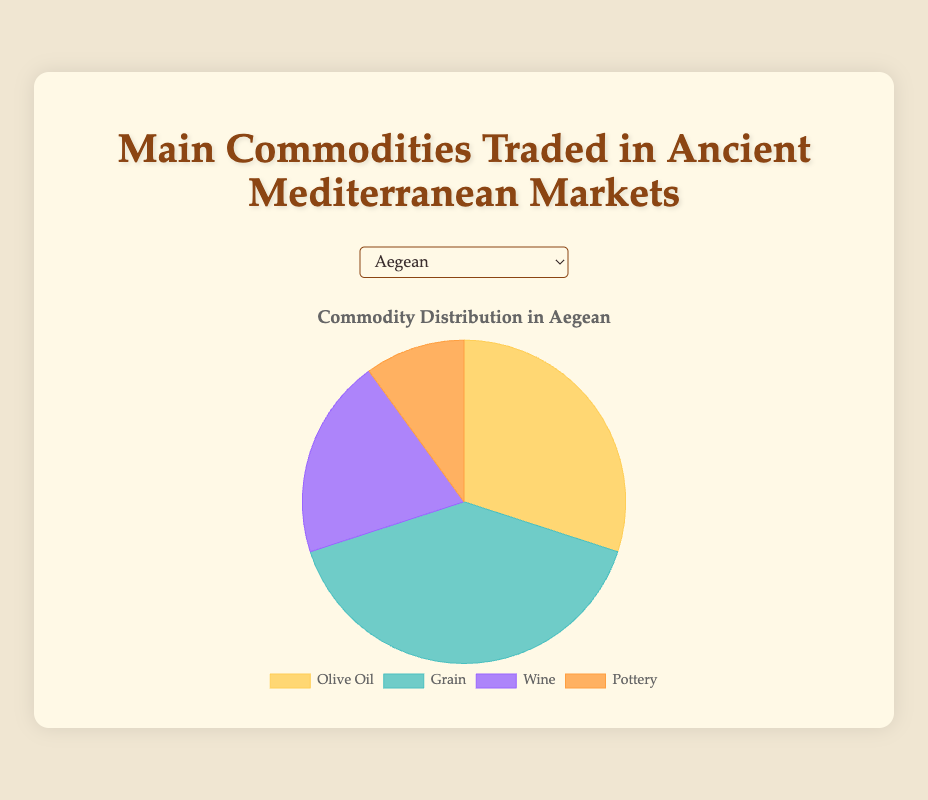What percentage of the commodities in the Aegean region is Olive Oil? To find this, refer to the pie chart for the Aegean region. Olive Oil represents 30% of the commodities in this chart.
Answer: 30% Which region has the highest proportion of Grain trade? Look at all the pie charts and identify the region with the largest segment for Grain. The Northern Africa region has the largest proportion of Grain trade at 50%.
Answer: Northern Africa How do the percentages of Olive Oil and Wine in the Western Mediterranean compare? In the Western Mediterranean pie chart, Olive Oil makes up 40% and Wine makes up 20%. Thus, Olive Oil is twice as much as Wine.
Answer: Olive Oil is twice Wine In which region does Pottery have the largest proportional trade? Check all the pie charts to find the region where the Pottery segment is the largest. The Levant region has the highest proportion of Pottery at 15%.
Answer: Levant What is the total percentage for Grain and Wine in the Levant region? In Levant, Grain is 35% and Wine is 25%. Adding them gives 35% + 25% = 60%.
Answer: 60% Which commodity has the smallest proportion in the Aegean region? Look at the Aegean pie chart; the smallest section is for Pottery at 10%.
Answer: Pottery Compare the Grain trade proportions between the Aegean and Western Mediterranean regions? In the Aegean region, Grain is 40%. In the Western Mediterranean, it is 30%. Therefore, Grain trade is higher in the Aegean region.
Answer: Grain is higher in Aegean How does the proportion of Olive Oil in Northern Africa compare to that in the Aegean region? Olive Oil in Northern Africa is 20%, while in the Aegean region, it is 30%. Thus, Olive Oil is more significant in the Aegean region by 10%.
Answer: Aegean is 10% more If you combine the percentages of Wine and Pottery in the Northern Africa region, what proportion do they represent? In Northern Africa, Wine is 10%, and Pottery is 20%. Adding them gives 10% + 20% = 30%.
Answer: 30% Which region has the smallest proportion of Wine trade? Check all the pie charts and find the region where the Wine segment is the smallest. Northern Africa has the smallest proportion of Wine at 10%.
Answer: Northern Africa 